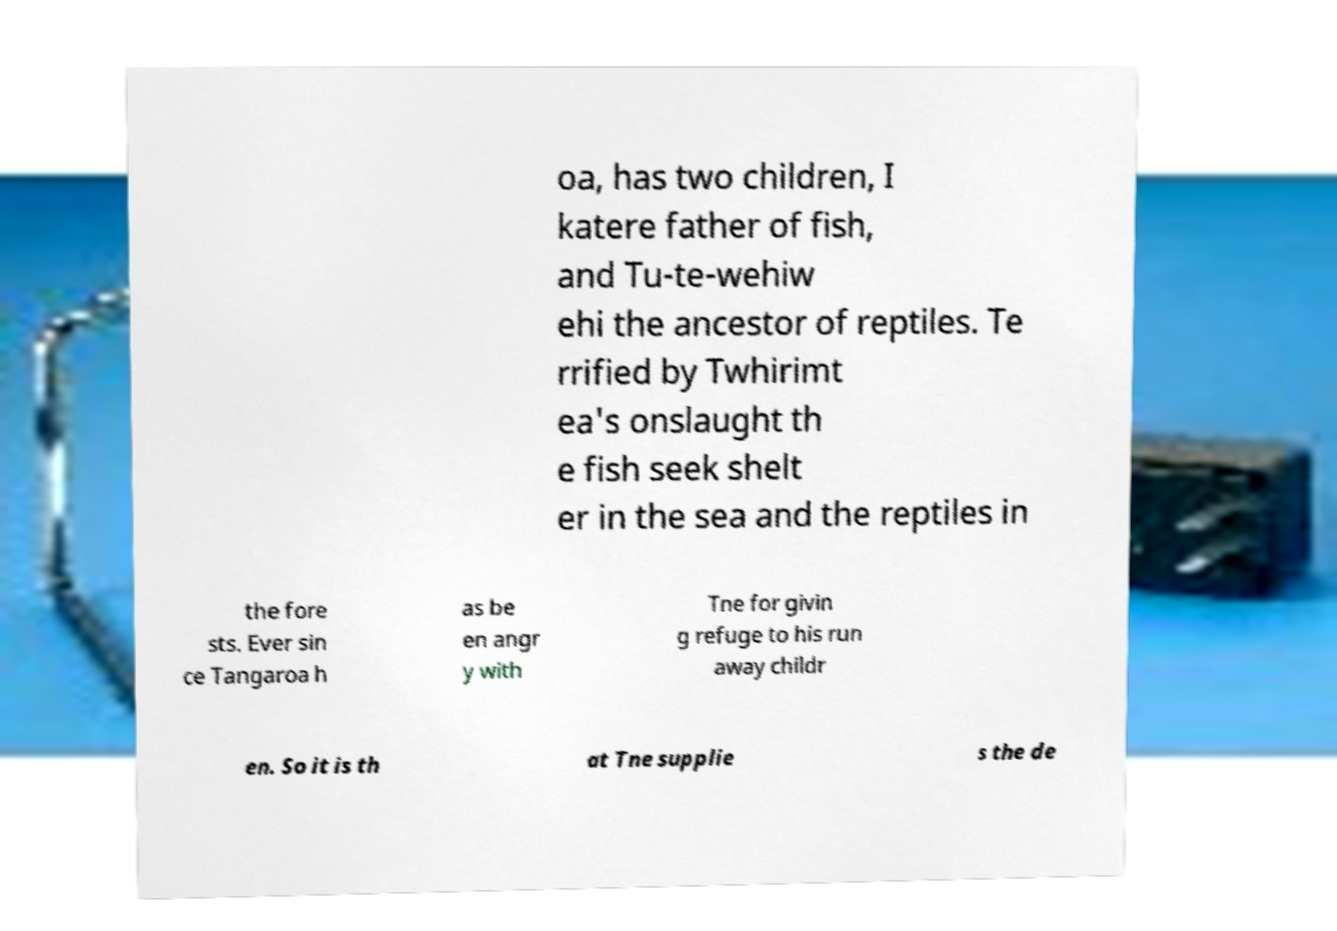Please read and relay the text visible in this image. What does it say? oa, has two children, I katere father of fish, and Tu-te-wehiw ehi the ancestor of reptiles. Te rrified by Twhirimt ea's onslaught th e fish seek shelt er in the sea and the reptiles in the fore sts. Ever sin ce Tangaroa h as be en angr y with Tne for givin g refuge to his run away childr en. So it is th at Tne supplie s the de 